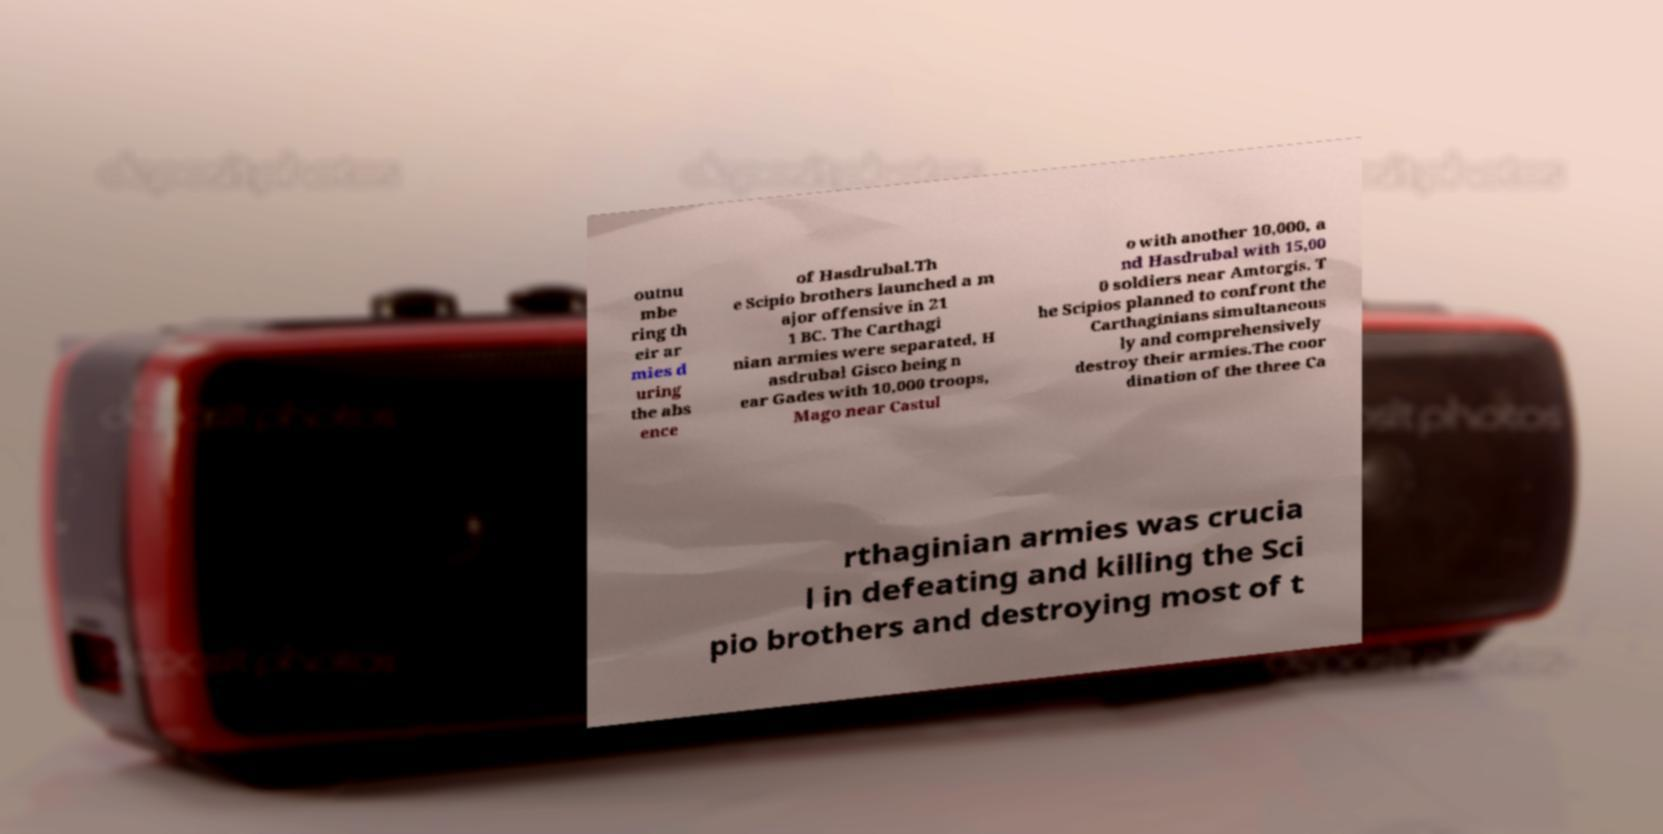Could you assist in decoding the text presented in this image and type it out clearly? outnu mbe ring th eir ar mies d uring the abs ence of Hasdrubal.Th e Scipio brothers launched a m ajor offensive in 21 1 BC. The Carthagi nian armies were separated, H asdrubal Gisco being n ear Gades with 10,000 troops, Mago near Castul o with another 10,000, a nd Hasdrubal with 15,00 0 soldiers near Amtorgis. T he Scipios planned to confront the Carthaginians simultaneous ly and comprehensively destroy their armies.The coor dination of the three Ca rthaginian armies was crucia l in defeating and killing the Sci pio brothers and destroying most of t 